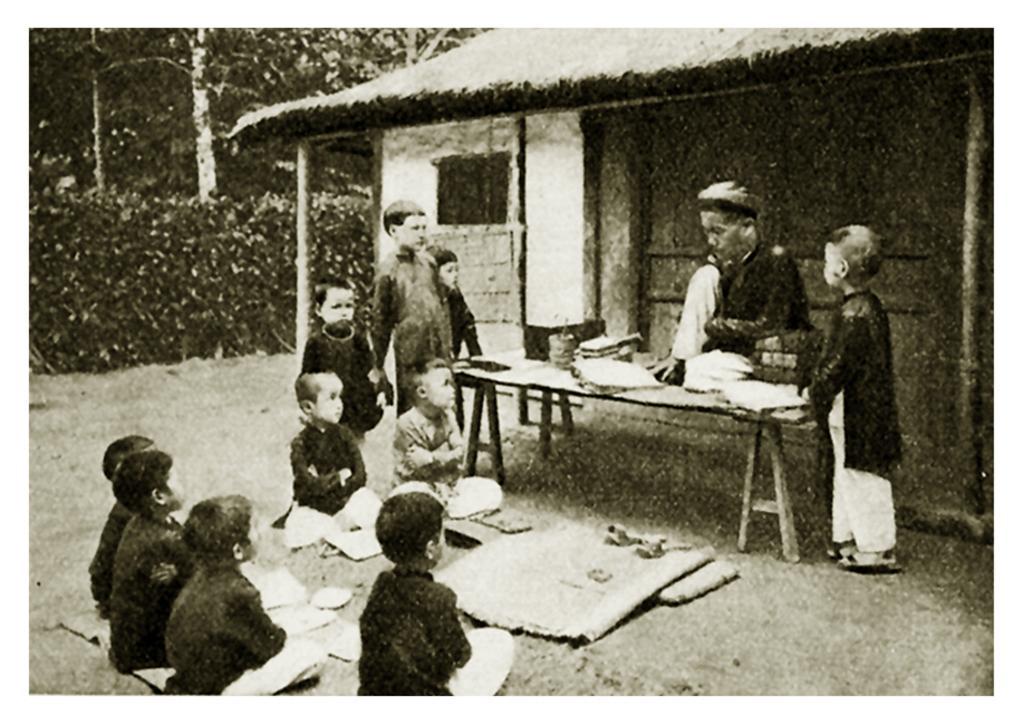Could you give a brief overview of what you see in this image? In this image there are few children sitting down on the floor and listening to the elder man who is sitting on the table. There are also few children standing beside the table and looking at the elder man. There is a hut behind him in this picture and also there are few trees in the background. 